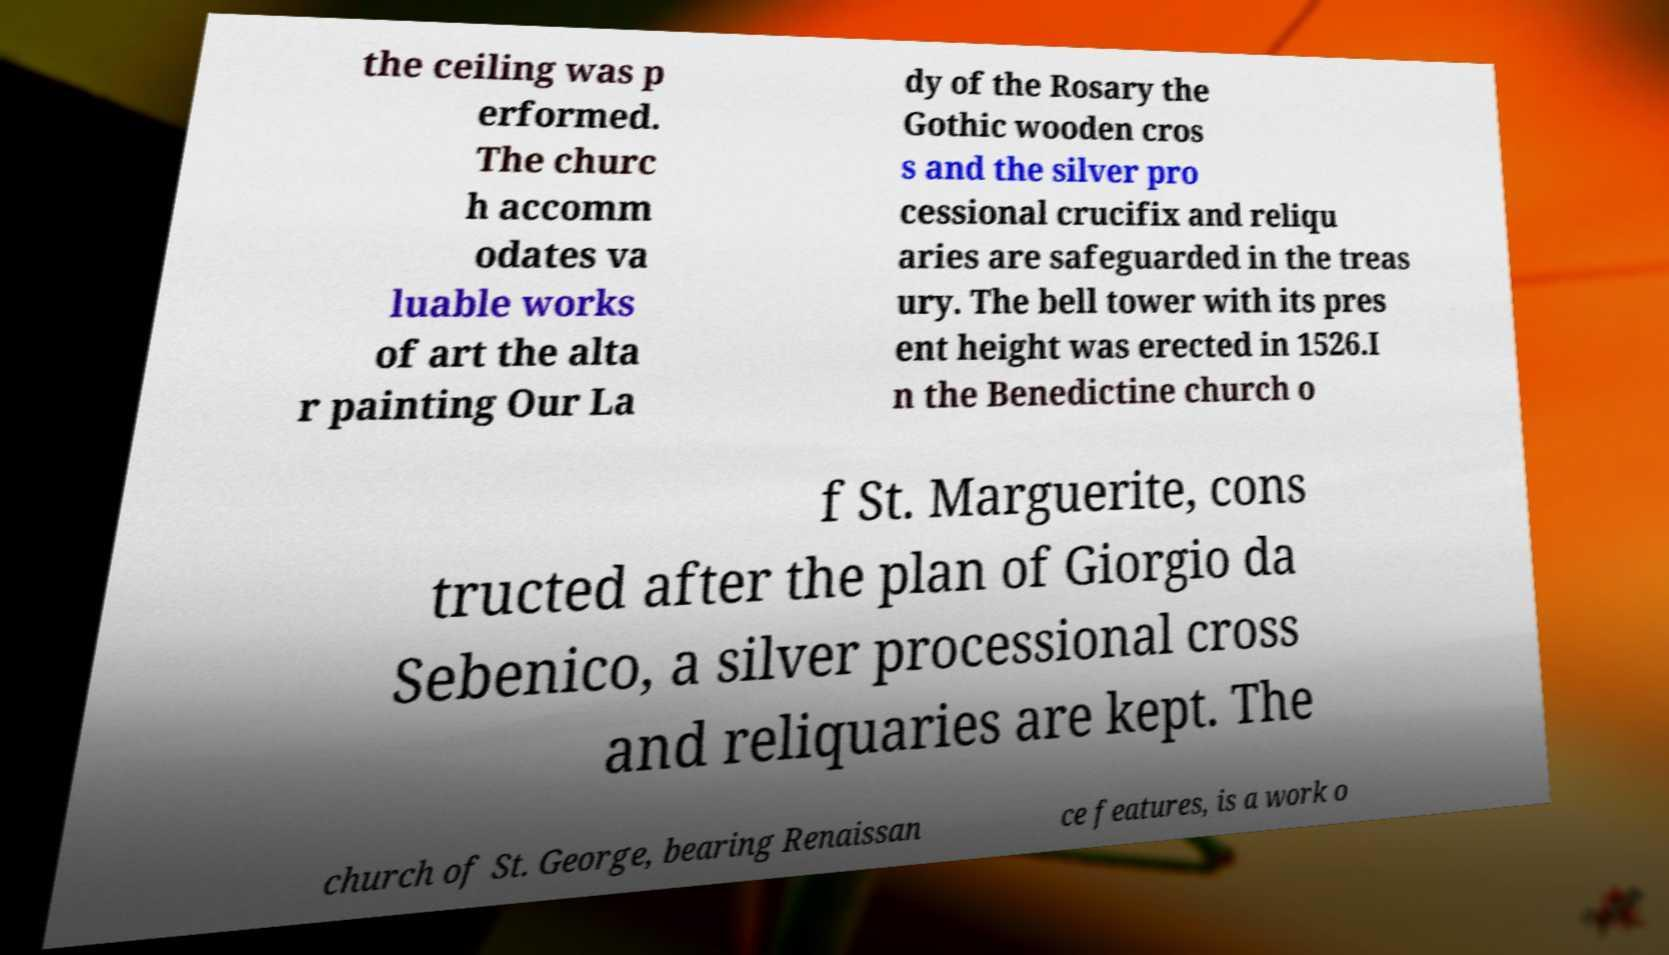There's text embedded in this image that I need extracted. Can you transcribe it verbatim? the ceiling was p erformed. The churc h accomm odates va luable works of art the alta r painting Our La dy of the Rosary the Gothic wooden cros s and the silver pro cessional crucifix and reliqu aries are safeguarded in the treas ury. The bell tower with its pres ent height was erected in 1526.I n the Benedictine church o f St. Marguerite, cons tructed after the plan of Giorgio da Sebenico, a silver processional cross and reliquaries are kept. The church of St. George, bearing Renaissan ce features, is a work o 